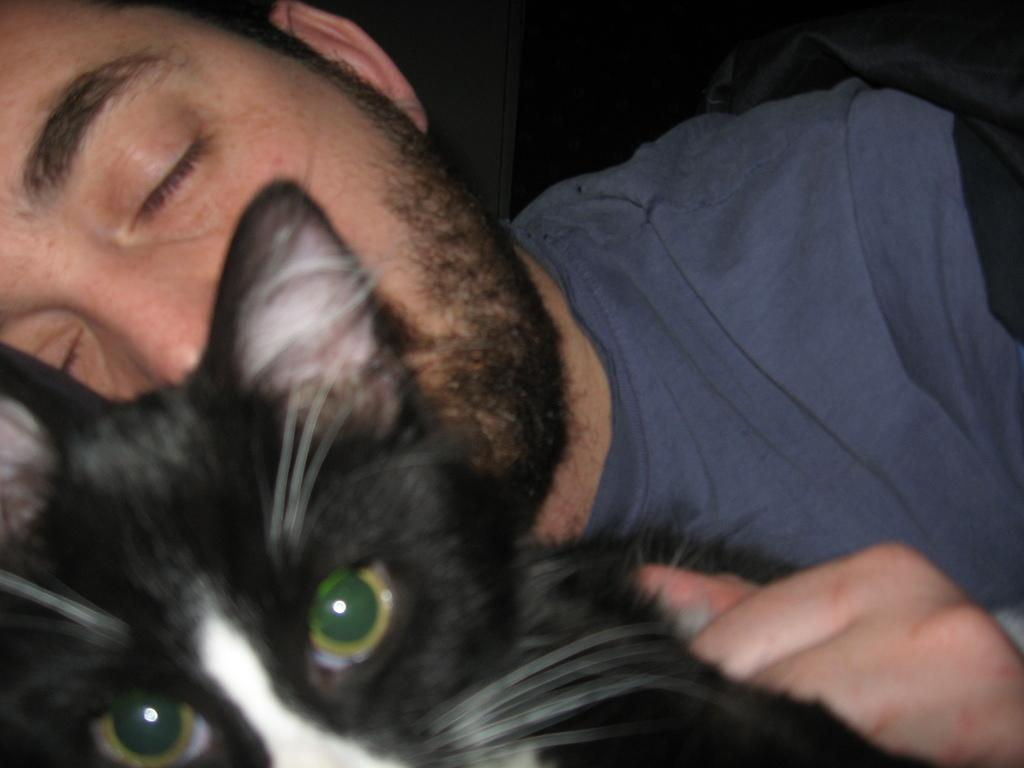What is the main subject of the image? There is a man in the image. What is the man wearing? The man is wearing a blue t-shirt. What is the man holding in his hand? The man is carrying a black cat in his hand. Can you describe the man's position in the image? The man may be lying on a bed. Are there any insects visible in the image? No, there are no insects visible in the image. 